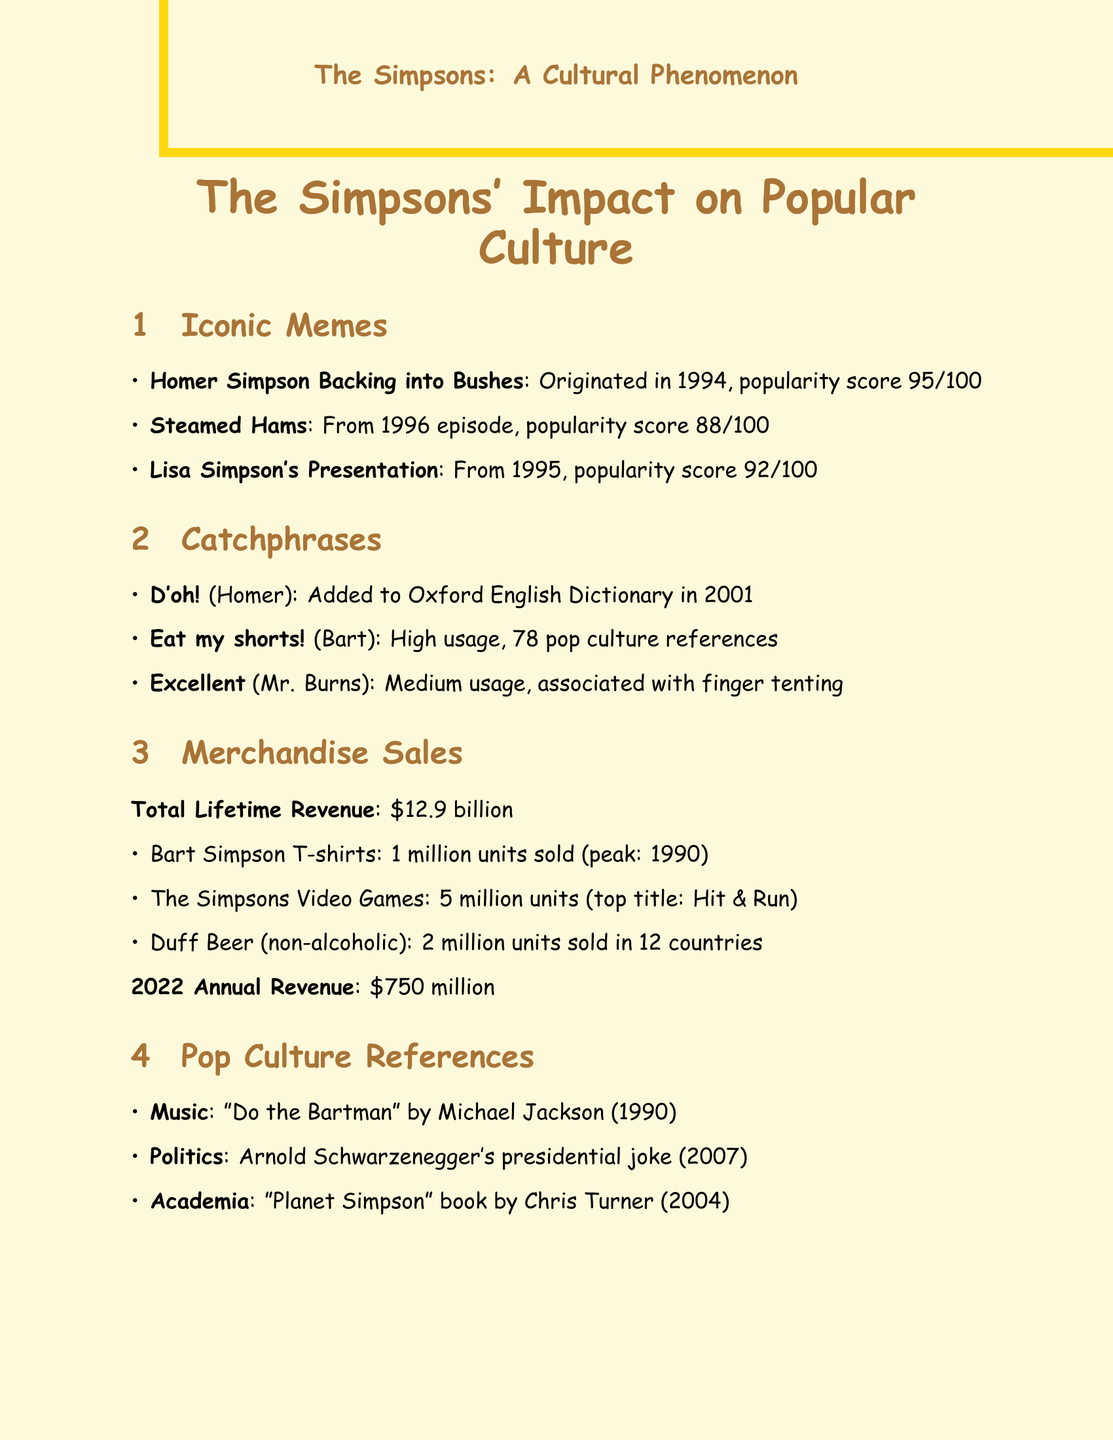What is the popularity score of the Homer Simpson meme? The popularity score of the Homer Simpson meme is indicated in the document, which is 95.
Answer: 95 In what year was the phrase "D'oh!" added to the Oxford English Dictionary? The document states that "D'oh!" was added to the Oxford English Dictionary in 2001.
Answer: 2001 What is the total lifetime revenue of The Simpsons merchandise? The total lifetime revenue is explicitly mentioned in the document as $12.9 billion.
Answer: $12.9 billion Which character's catchphrase is "Eat my shorts!"? The document indicates that "Eat my shorts!" is associated with Bart Simpson.
Answer: Bart Simpson How many units of Bart Simpson T-shirts were sold? The document provides the information that 1 million units of Bart Simpson T-shirts were sold.
Answer: 1 million What is the peak year for Bart Simpson T-shirt sales? According to the document, the peak year for Bart Simpson T-shirt sales is 1990.
Answer: 1990 Which episode predicted Donald Trump's presidency? The document lists "Bart to the Future" as the episode that predicted Donald Trump's presidency.
Answer: Bart to the Future How many times did Stephen Hawking appear on the show? The document states that Stephen Hawking appeared on the show 4 times.
Answer: 4 What year did the "Do the Bartman" song top the charts? The document specifies that "Do the Bartman" topped the charts in 1990.
Answer: 1990 